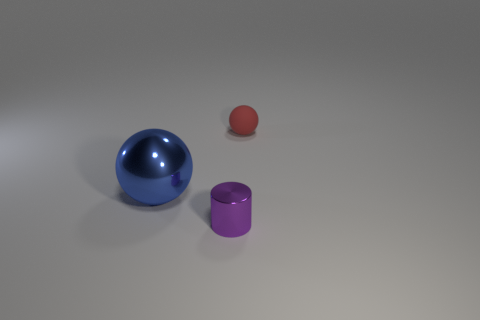Is there any other thing that is the same material as the red sphere?
Offer a terse response. No. What is the material of the thing that is behind the small shiny thing and on the right side of the blue metal sphere?
Give a very brief answer. Rubber. What is the color of the thing that is both on the left side of the tiny red sphere and behind the small metal object?
Provide a short and direct response. Blue. There is a ball to the right of the tiny purple cylinder; is it the same size as the object that is in front of the large ball?
Your answer should be very brief. Yes. How many large metallic balls have the same color as the small cylinder?
Give a very brief answer. 0. What number of small things are either gray rubber cubes or metal objects?
Provide a short and direct response. 1. Does the small object that is in front of the tiny red sphere have the same material as the big sphere?
Keep it short and to the point. Yes. The object behind the blue metallic thing is what color?
Provide a short and direct response. Red. Is there a purple metallic object that has the same size as the red rubber thing?
Provide a short and direct response. Yes. What is the material of the sphere that is the same size as the purple metallic object?
Make the answer very short. Rubber. 